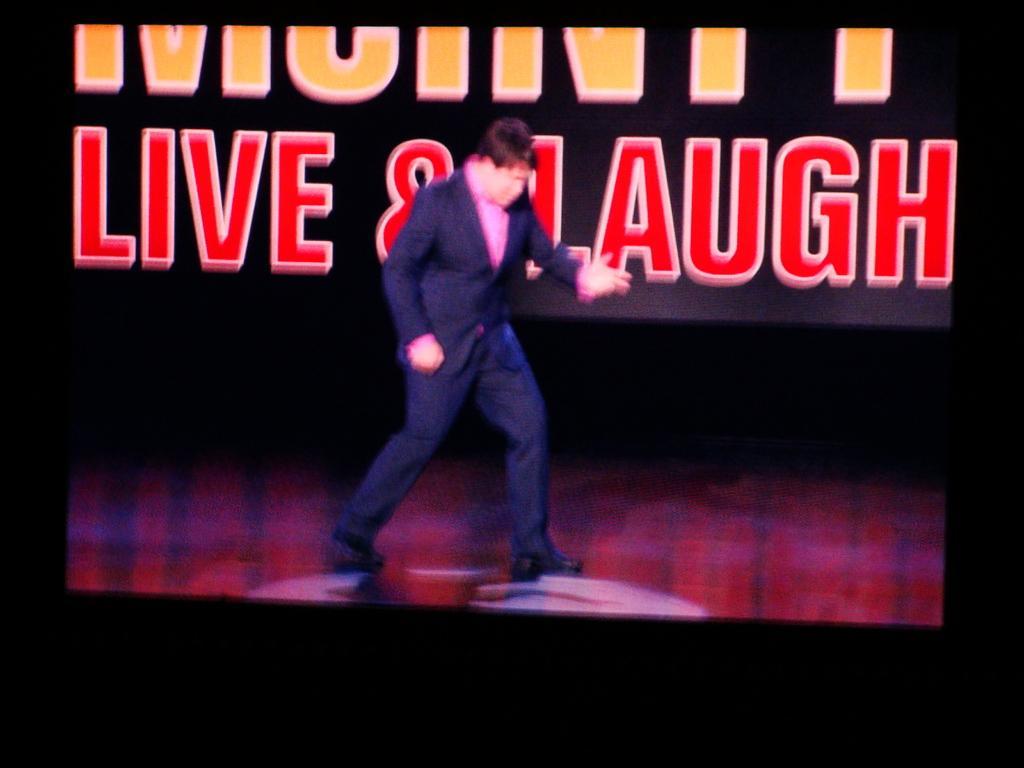Can you describe this image briefly? In this picture we can see a person on the stage and in the background we can see some text on it. 